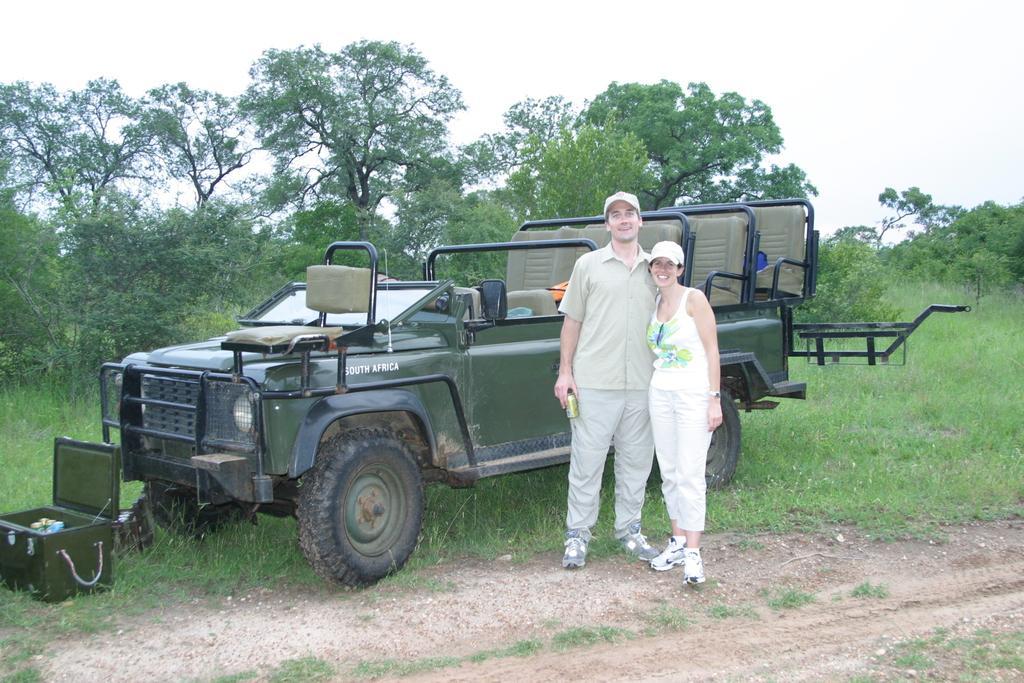Describe this image in one or two sentences. In this picture we can observe a couple. Both of them were wearing white color caps on their heads and smiling. Behind the couple there is a jeep which is in green color parked on the ground. In front of the jeep there is a box. We can observe some grass on the ground. In the background there are trees and a sky. 